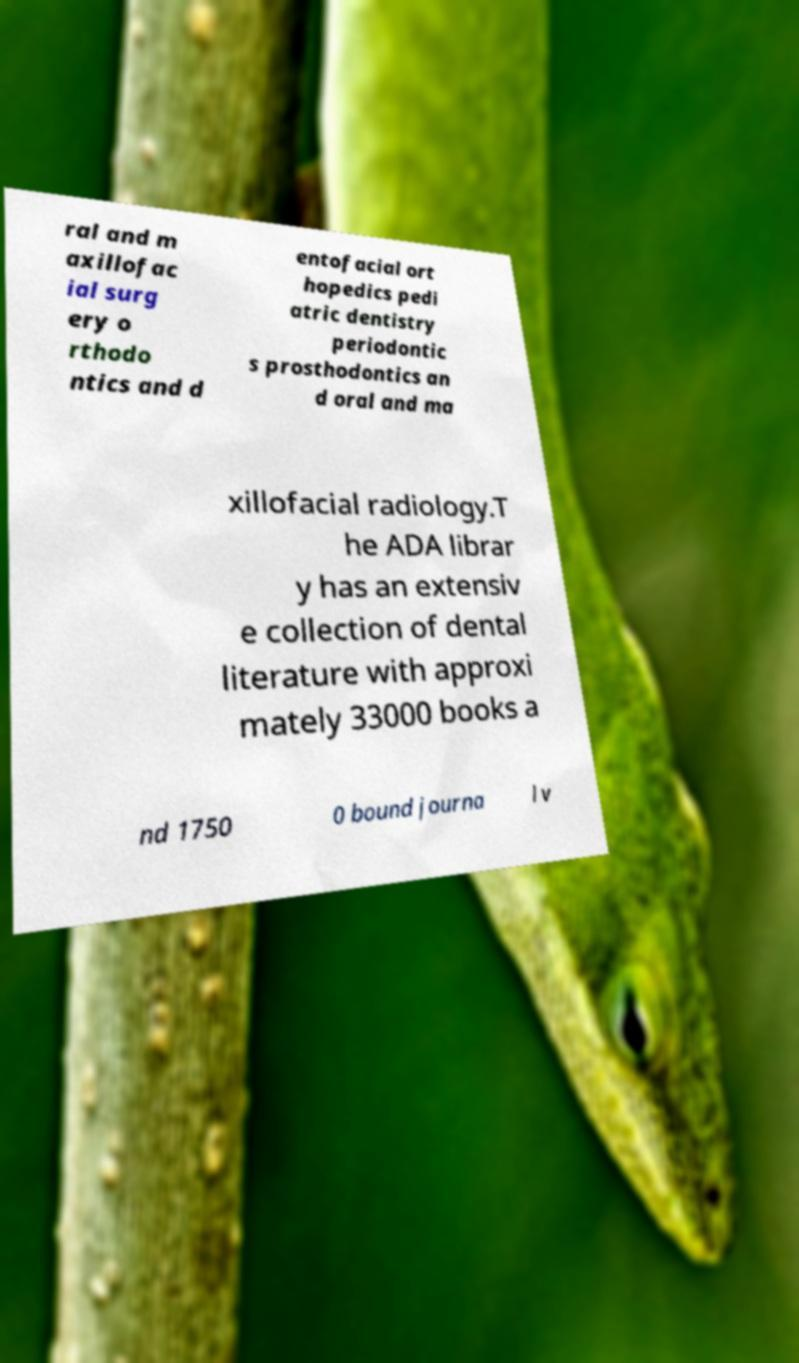Please read and relay the text visible in this image. What does it say? ral and m axillofac ial surg ery o rthodo ntics and d entofacial ort hopedics pedi atric dentistry periodontic s prosthodontics an d oral and ma xillofacial radiology.T he ADA librar y has an extensiv e collection of dental literature with approxi mately 33000 books a nd 1750 0 bound journa l v 